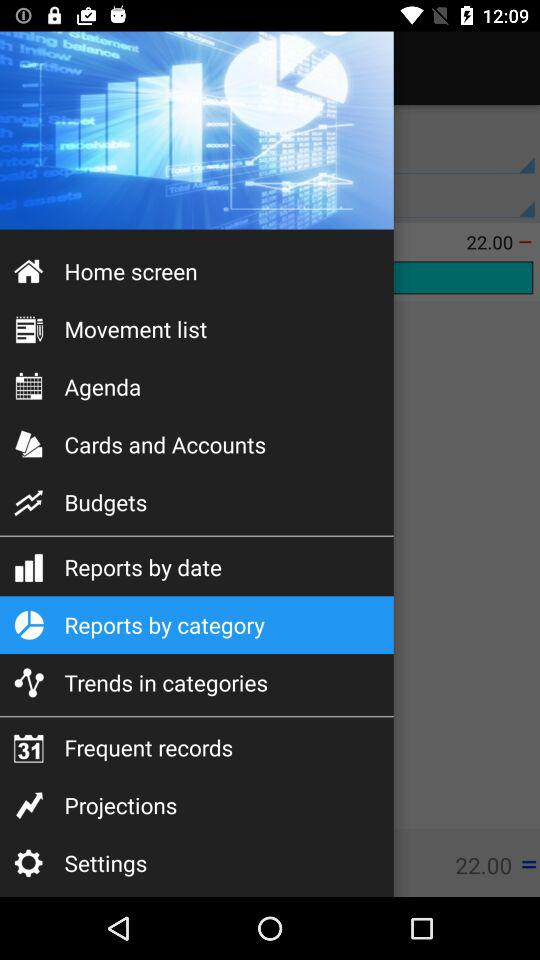What's the selected menu item? The selected menu item is "Reports by category". 